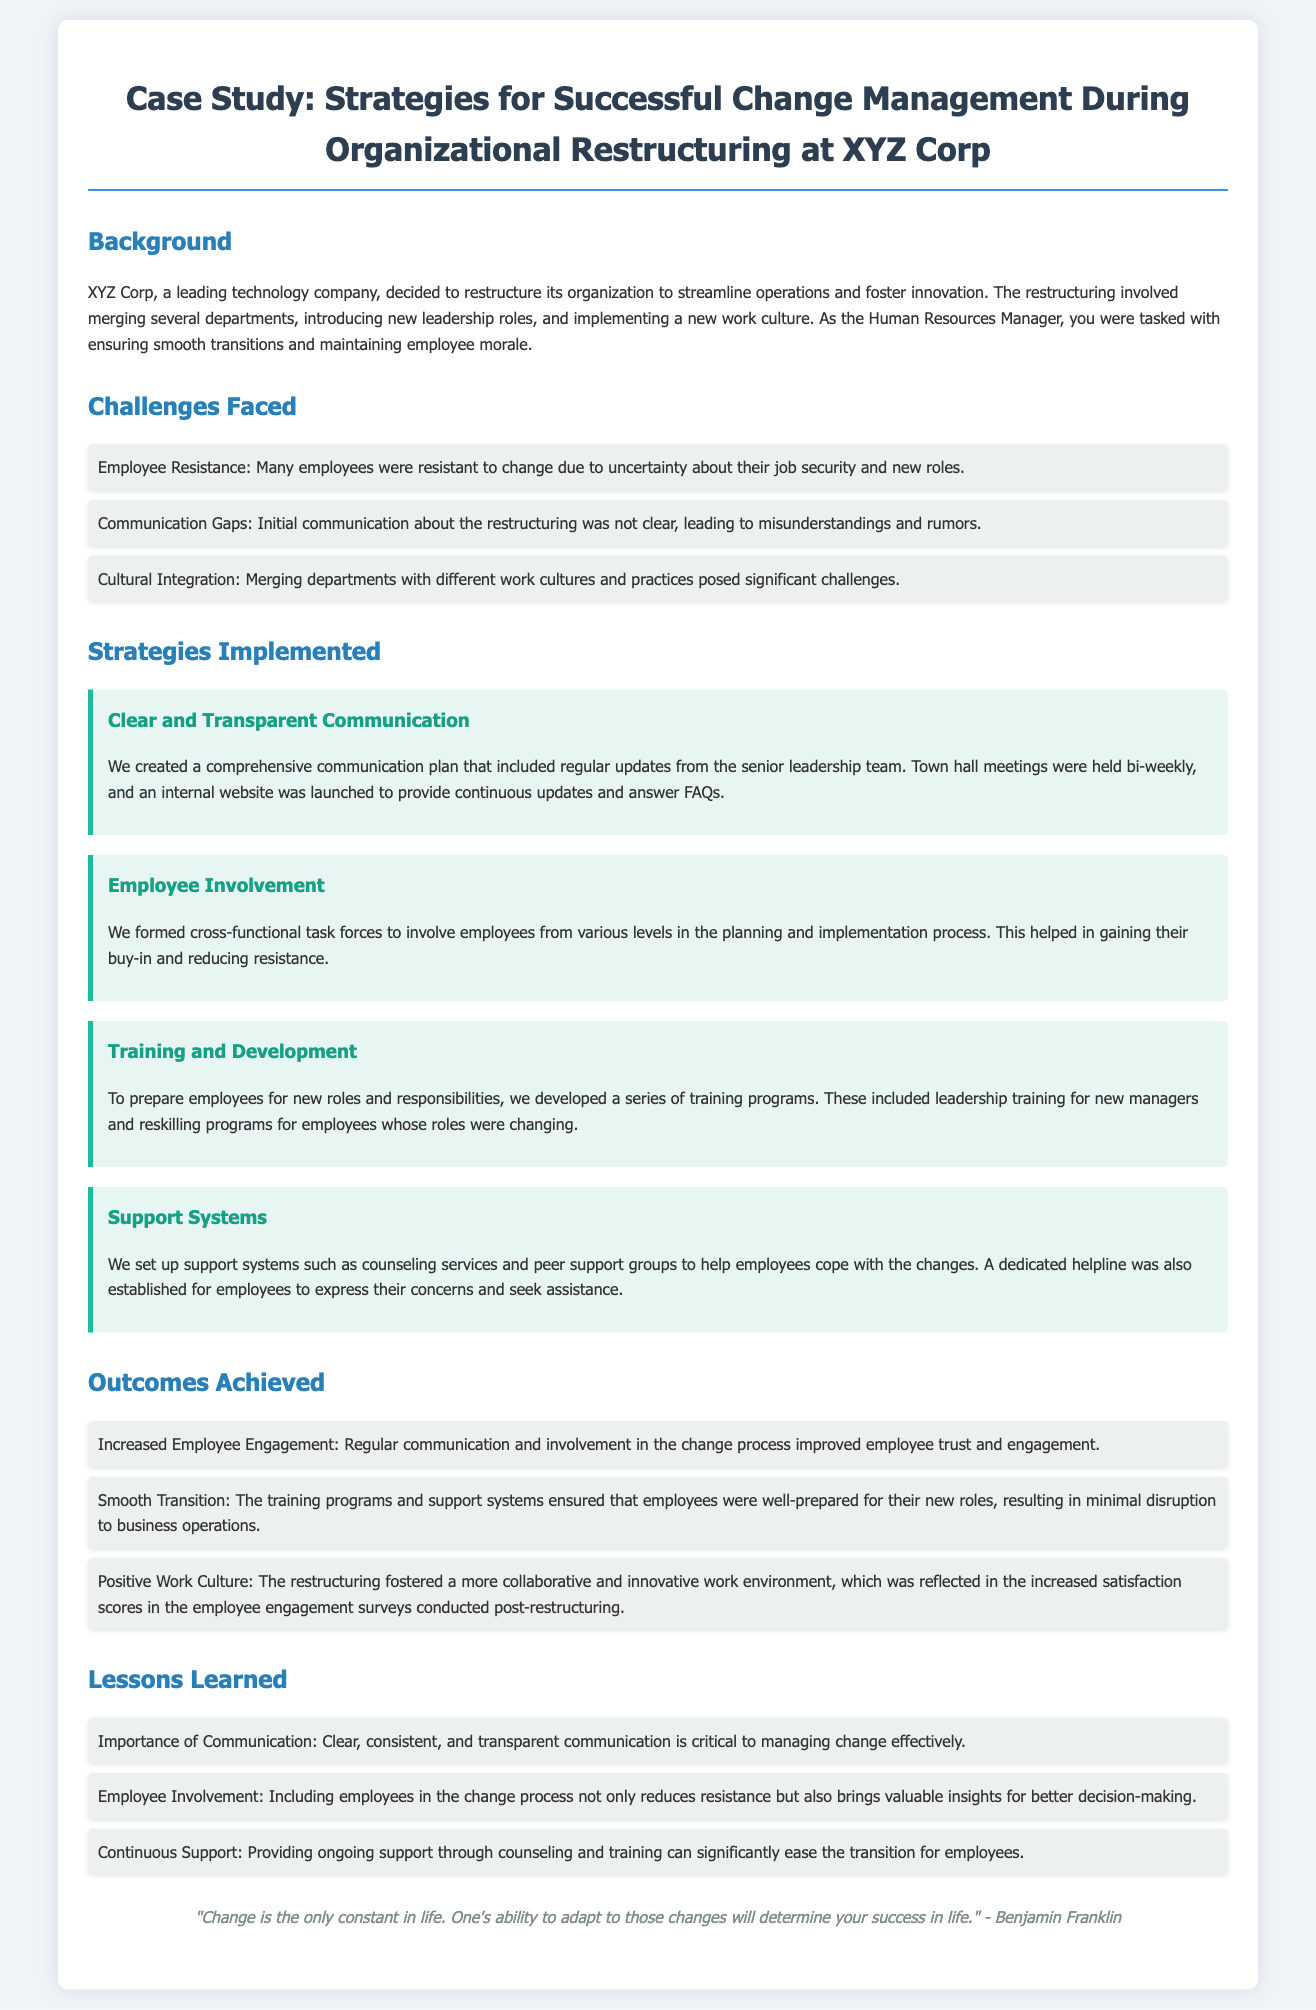What is the title of the case study? The title of the case study is mentioned at the top of the document.
Answer: Strategies for Successful Change Management During Organizational Restructuring at XYZ Corp What were the main challenges faced during the restructuring? The challenges are listed in a bullet format under the "Challenges Faced" section.
Answer: Employee Resistance, Communication Gaps, Cultural Integration How often were town hall meetings held? The document specifies the frequency of town hall meetings under the strategies implemented.
Answer: Bi-weekly What type of training programs were developed? The document outlines the type of programs created to assist employees in new roles.
Answer: Leadership training and reskilling programs What was one outcome achieved from the restructuring? The outcomes are listed under the "Outcomes Achieved" section.
Answer: Increased Employee Engagement What is one lesson learned from this change management process? The lessons are highlighted under the "Lessons Learned" section and provide insights gained.
Answer: Importance of Communication Who was responsible for maintaining employee morale during the restructuring? The document assigns a specific role related to maintaining morale during the process.
Answer: Human Resources Manager What did the restructuring foster in the work environment? The document indicates a specific improvement in the work environment as a result of the restructuring.
Answer: Collaborative and innovative work environment 